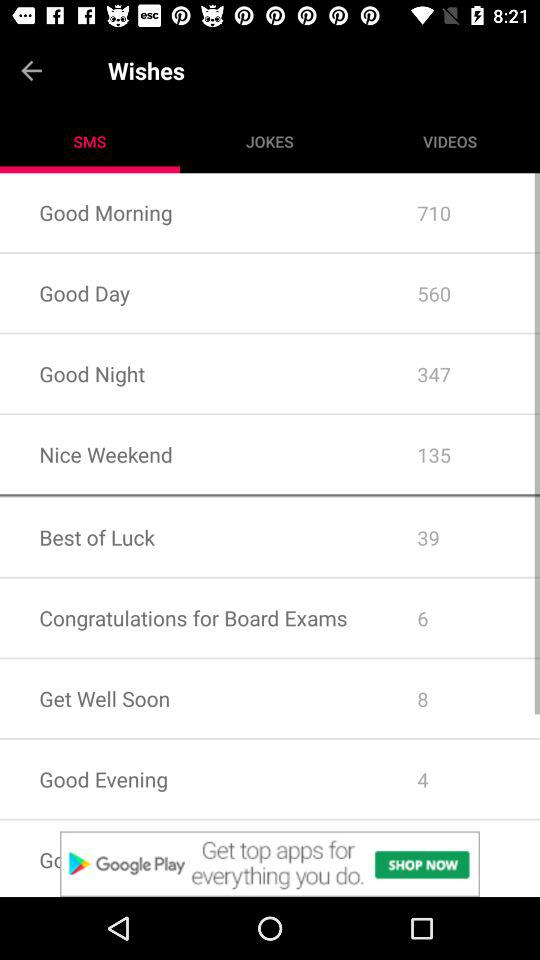How many messages are there for "Good Morning"? There are 710 messages. 